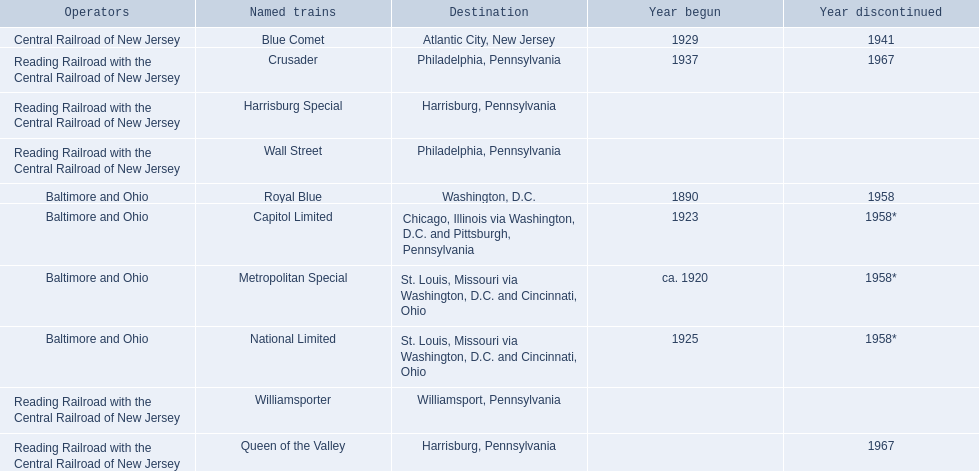Which of the trains are operated by reading railroad with the central railroad of new jersey? Crusader, Harrisburg Special, Queen of the Valley, Wall Street, Williamsporter. Of these trains, which of them had a destination of philadelphia, pennsylvania? Crusader, Wall Street. Out of these two trains, which one is discontinued? Crusader. 